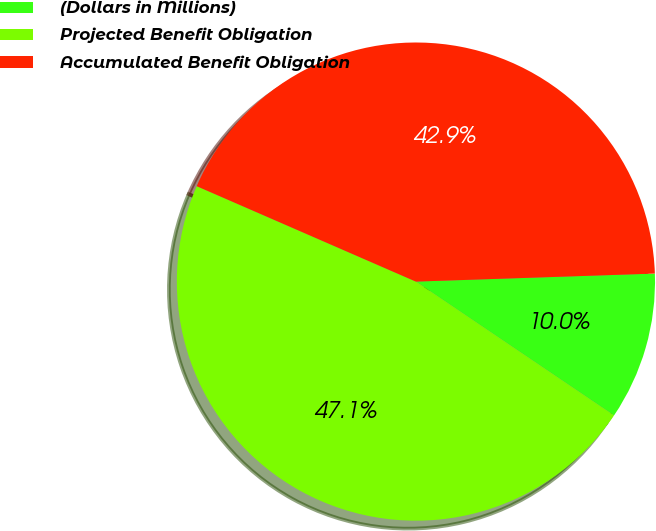<chart> <loc_0><loc_0><loc_500><loc_500><pie_chart><fcel>(Dollars in Millions)<fcel>Projected Benefit Obligation<fcel>Accumulated Benefit Obligation<nl><fcel>9.99%<fcel>47.08%<fcel>42.93%<nl></chart> 